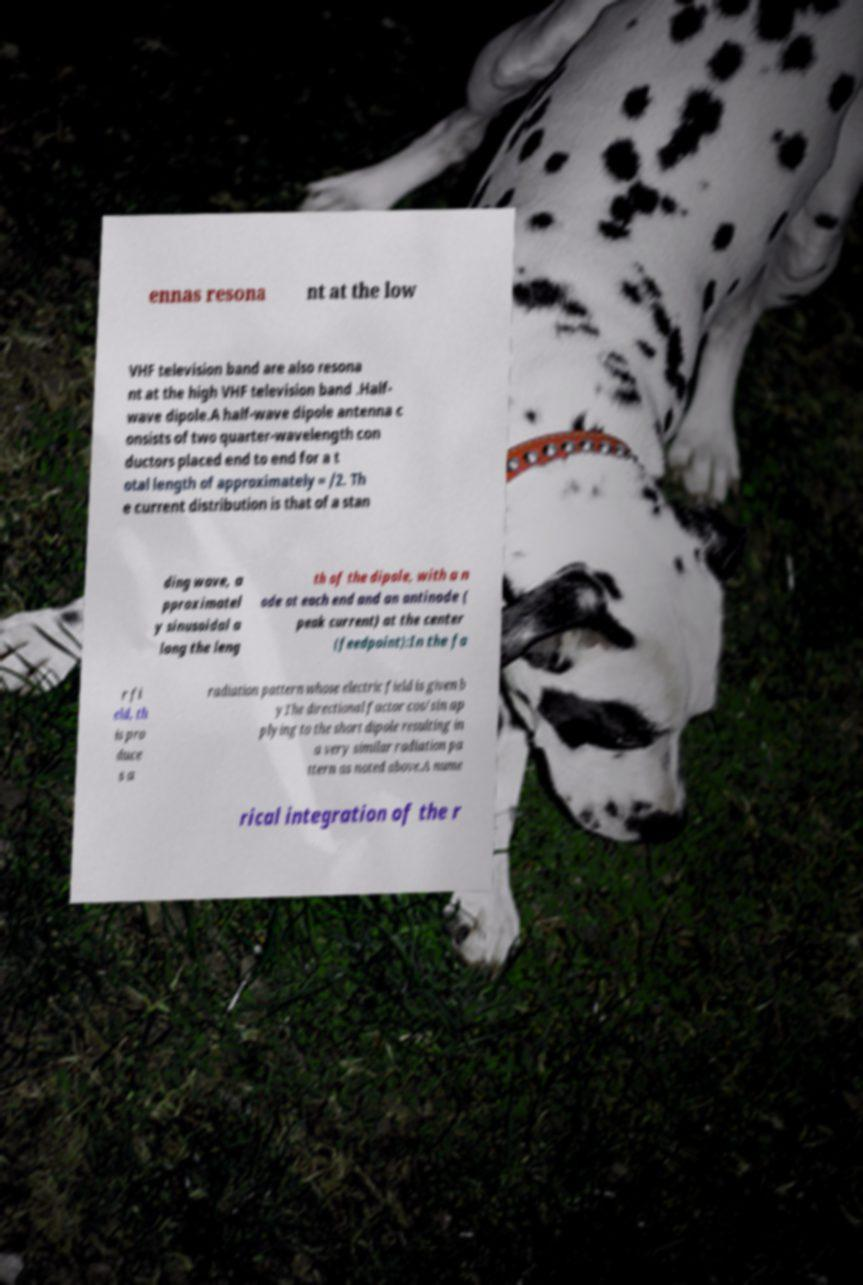Please identify and transcribe the text found in this image. ennas resona nt at the low VHF television band are also resona nt at the high VHF television band .Half- wave dipole.A half-wave dipole antenna c onsists of two quarter-wavelength con ductors placed end to end for a t otal length of approximately = /2. Th e current distribution is that of a stan ding wave, a pproximatel y sinusoidal a long the leng th of the dipole, with a n ode at each end and an antinode ( peak current) at the center (feedpoint):In the fa r fi eld, th is pro duce s a radiation pattern whose electric field is given b yThe directional factor cos/sin ap plying to the short dipole resulting in a very similar radiation pa ttern as noted above.A nume rical integration of the r 